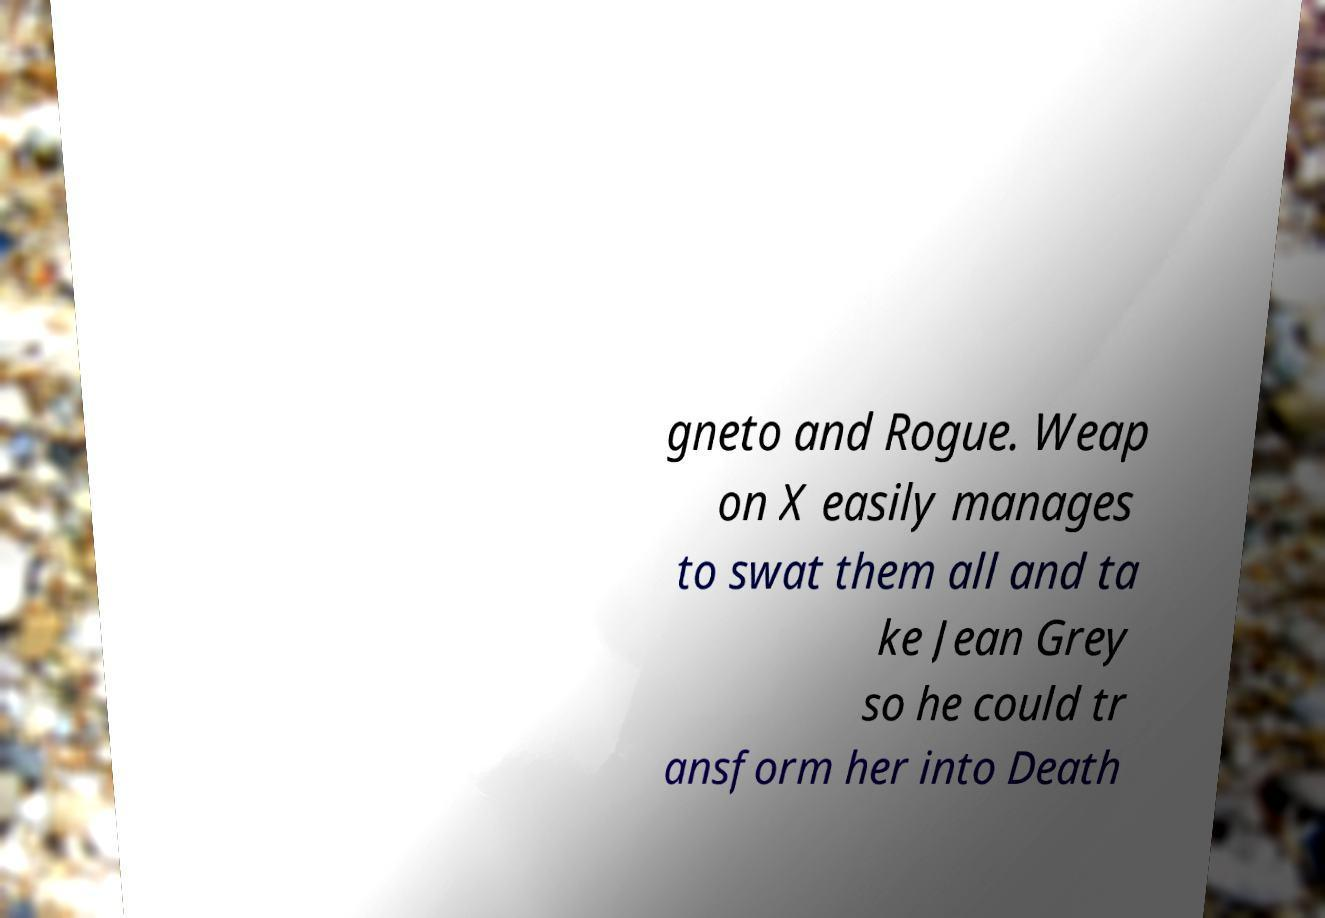Could you extract and type out the text from this image? gneto and Rogue. Weap on X easily manages to swat them all and ta ke Jean Grey so he could tr ansform her into Death 